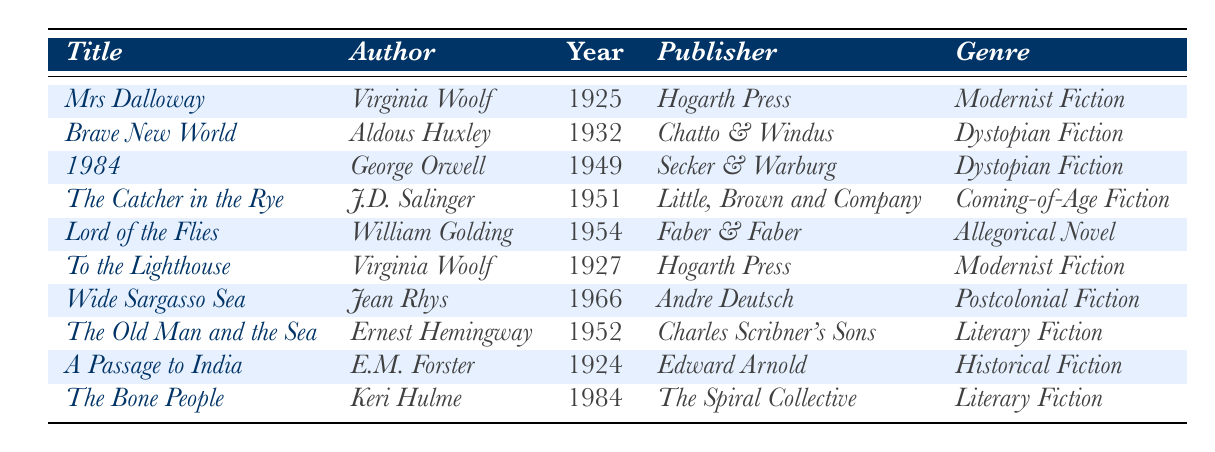What is the title of the novel published in 1925? By looking at the table, the novel listed with the publication year 1925 is "Mrs Dalloway."
Answer: Mrs Dalloway Who is the author of "1984"? The table shows that the author listed next to the title "1984" is George Orwell.
Answer: George Orwell How many novels were published in the 1950s? The table lists three novels under the publication years 1951 (The Catcher in the Rye), 1952 (The Old Man and the Sea), and 1954 (Lord of the Flies). Thus, the total count is 3.
Answer: 3 Which genre is the most represented in the table? The table contains multiple genres, but Modernist Fiction (2 entries: "Mrs Dalloway" and "To the Lighthouse") and Dystopian Fiction (2 entries: "Brave New World" and "1984") are tied for the most.
Answer: Modernist Fiction and Dystopian Fiction Was "A Passage to India" published before or after 1930? Looking at the publication year of "A Passage to India," it is listed as 1924, which means it was published before 1930.
Answer: Before Which novel was published by Hogarth Press? The table shows two novels published by Hogarth Press: "Mrs Dalloway" and "To the Lighthouse."
Answer: Mrs Dalloway and To the Lighthouse What is the difference in publication years between "Wide Sargasso Sea" and "Brave New World"? "Wide Sargasso Sea" was published in 1966, and "Brave New World" in 1932. The difference is 1966 - 1932 = 634 years.
Answer: 34 years Is "The Bone People" a postcolonial fiction? The genre listed for "The Bone People" in the table is Postcolonial Fiction, which makes this statement true.
Answer: Yes Which author has the most works listed in the table? Virginia Woolf has two works listed: "Mrs Dalloway" and "To the Lighthouse." Other authors have one work each, making her the most represented.
Answer: Virginia Woolf Can you list all genres present in the table? The table presents the following genres: Modernist Fiction, Dystopian Fiction, Coming-of-Age Fiction, Allegorical Novel, Literary Fiction, Historical Fiction, and Postcolonial Fiction.
Answer: Modernist Fiction, Dystopian Fiction, Coming-of-Age Fiction, Allegorical Novel, Literary Fiction, Historical Fiction, Postcolonial Fiction 